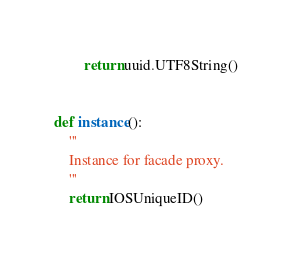Convert code to text. <code><loc_0><loc_0><loc_500><loc_500><_Python_>        return uuid.UTF8String()


def instance():
    '''
    Instance for facade proxy.
    '''
    return IOSUniqueID()
</code> 